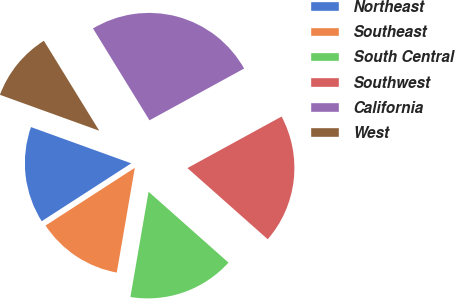<chart> <loc_0><loc_0><loc_500><loc_500><pie_chart><fcel>Northeast<fcel>Southeast<fcel>South Central<fcel>Southwest<fcel>California<fcel>West<nl><fcel>14.66%<fcel>13.15%<fcel>16.17%<fcel>19.52%<fcel>25.81%<fcel>10.7%<nl></chart> 